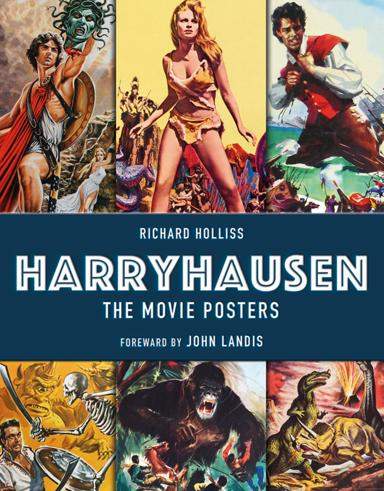Who is the author of the book about movie posters mentioned in the image? The author of the illustrated book is Richard Holliss. He has compiled a colorful and insightful collection showcasing the movie posters associated with the iconic film creations of Ray Harryhausen, revealing the influential art behind classic cinema. 